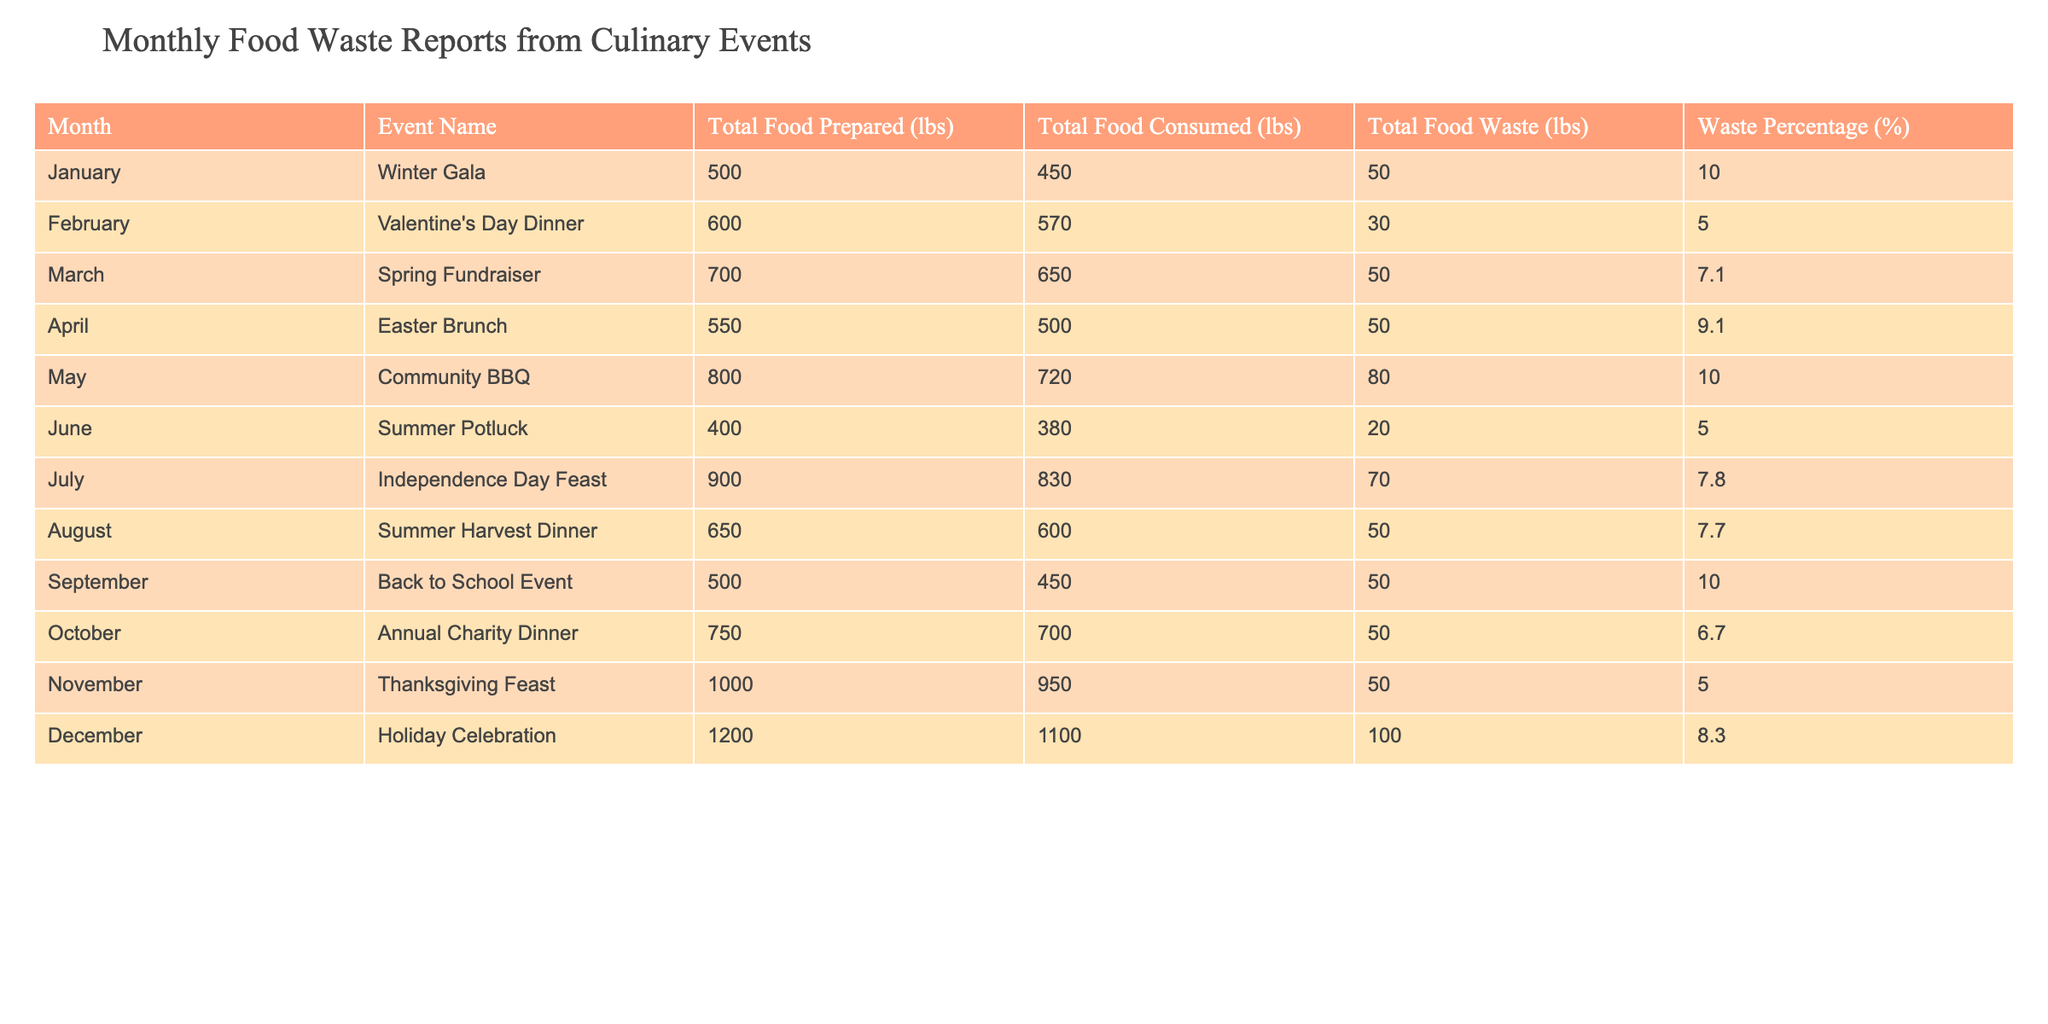What was the total food waste in December? In December, the table indicates that there was a total food waste of 100 lbs. This value is taken directly from the Total Food Waste (lbs) column for the Holiday Celebration event.
Answer: 100 lbs Which event had the highest waste percentage? The event with the highest waste percentage is the Community BBQ in May, with a waste percentage of 10.0%. This is found by comparing the Waste Percentage (%) column across all events, identifying that May's percentage is the highest noted in the table.
Answer: Community BBQ in May (10.0%) What is the average food waste for events from January to March? To find the average food waste from January to March, sum the food waste values: January (50 lbs) + February (30 lbs) + March (50 lbs) = 130 lbs. Then divide by the number of events, which is 3. Thus, the average is 130 lbs / 3 = 43.33 lbs.
Answer: 43.33 lbs Did any event have zero food waste? Looking through the Total Food Waste (lbs) column, there are no entries marked with zero food waste for any event. Each event listed has had some food waste recorded, thus the answer is false.
Answer: No How much total food was consumed during the Holiday Celebration? The table states that during the Holiday Celebration, a total of 1100 lbs of food was consumed. This value is found in the Total Food Consumed (lbs) column for December.
Answer: 1100 lbs What is the total food prepared for events with waste percentages higher than 9%? The total food prepared for events with waste percentages higher than 9% includes the Winter Gala (500 lbs), the Community BBQ (800 lbs), and the Winter Feast (1000 lbs). The total is 500 + 800 + 1000 = 2300 lbs.
Answer: 2300 lbs How many events had a waste percentage lower than 6%? By inspecting the Waste Percentage (%) column, only the Thanksgiving Feast in November (5.0%) has a waste percentage lower than 6%, totaling just one event.
Answer: 1 What was the food waste for the Independence Day Feast in July? According to the table, the food waste recorded for the Independence Day Feast in July is 70 lbs. This number can be found in the Total Food Waste (lbs) column.
Answer: 70 lbs 